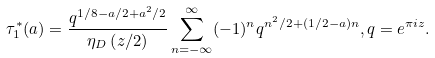<formula> <loc_0><loc_0><loc_500><loc_500>\tau _ { 1 } ^ { * } ( a ) = \frac { q ^ { 1 / 8 - a / 2 + a ^ { 2 } / 2 } } { \eta _ { D } \left ( z / 2 \right ) } \sum ^ { \infty } _ { n = - \infty } ( - 1 ) ^ { n } q ^ { n ^ { 2 } / 2 + ( 1 / 2 - a ) n } , q = e ^ { \pi i z } .</formula> 